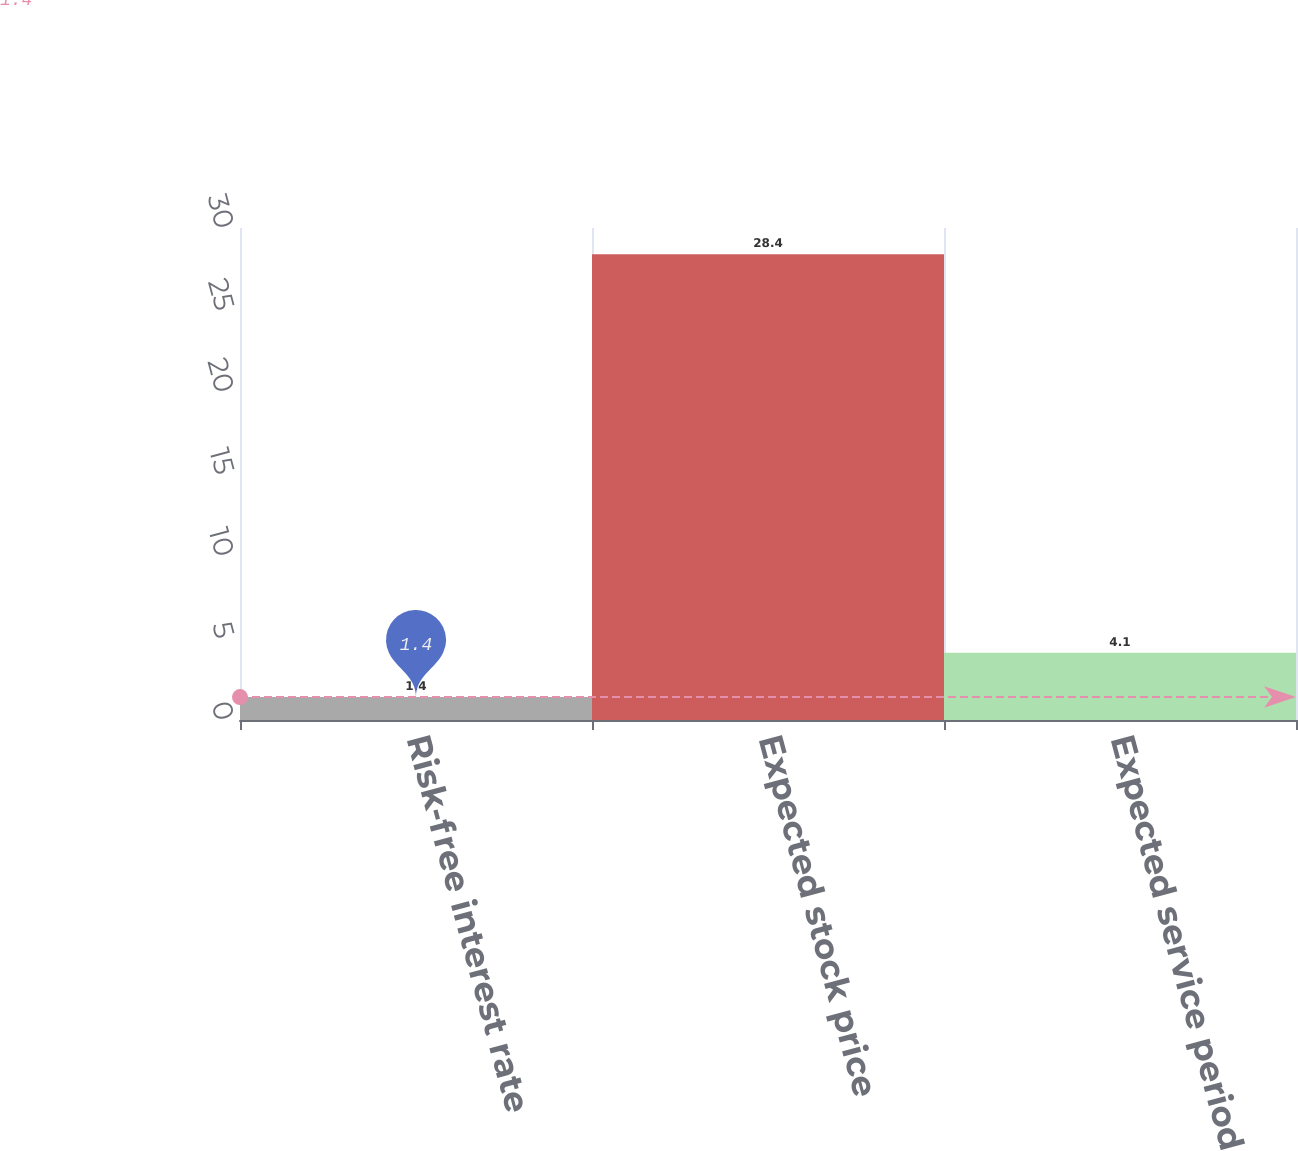Convert chart. <chart><loc_0><loc_0><loc_500><loc_500><bar_chart><fcel>Risk-free interest rate<fcel>Expected stock price<fcel>Expected service period<nl><fcel>1.4<fcel>28.4<fcel>4.1<nl></chart> 